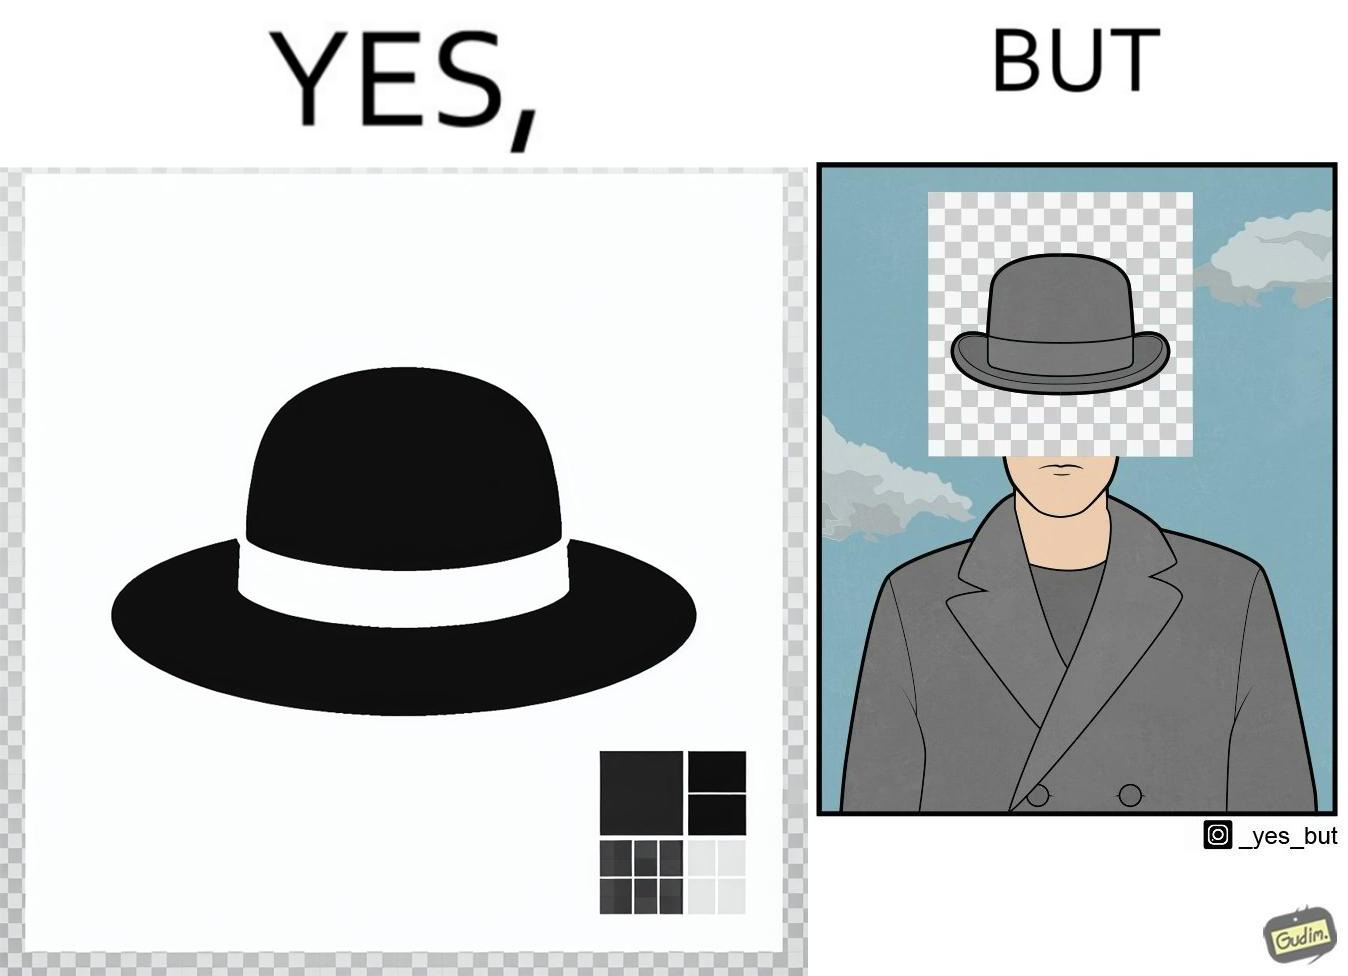Why is this image considered satirical? The images are funny since the .png image of the hat is supposed to have a transparent background but when the image is used for editing a mans picture it is seen that the background is not actually transparent and it ends up covering the face of the man in the other picture. 